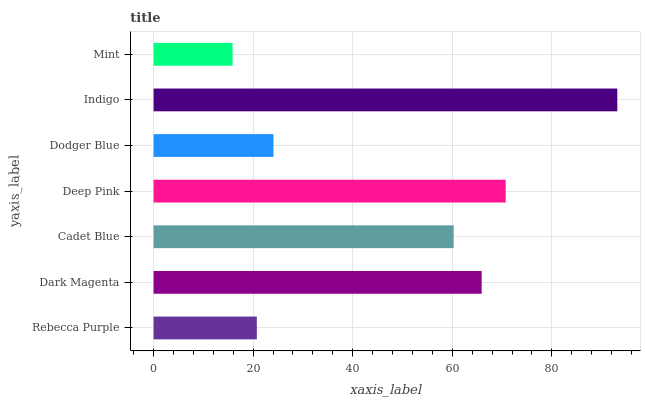Is Mint the minimum?
Answer yes or no. Yes. Is Indigo the maximum?
Answer yes or no. Yes. Is Dark Magenta the minimum?
Answer yes or no. No. Is Dark Magenta the maximum?
Answer yes or no. No. Is Dark Magenta greater than Rebecca Purple?
Answer yes or no. Yes. Is Rebecca Purple less than Dark Magenta?
Answer yes or no. Yes. Is Rebecca Purple greater than Dark Magenta?
Answer yes or no. No. Is Dark Magenta less than Rebecca Purple?
Answer yes or no. No. Is Cadet Blue the high median?
Answer yes or no. Yes. Is Cadet Blue the low median?
Answer yes or no. Yes. Is Dodger Blue the high median?
Answer yes or no. No. Is Deep Pink the low median?
Answer yes or no. No. 